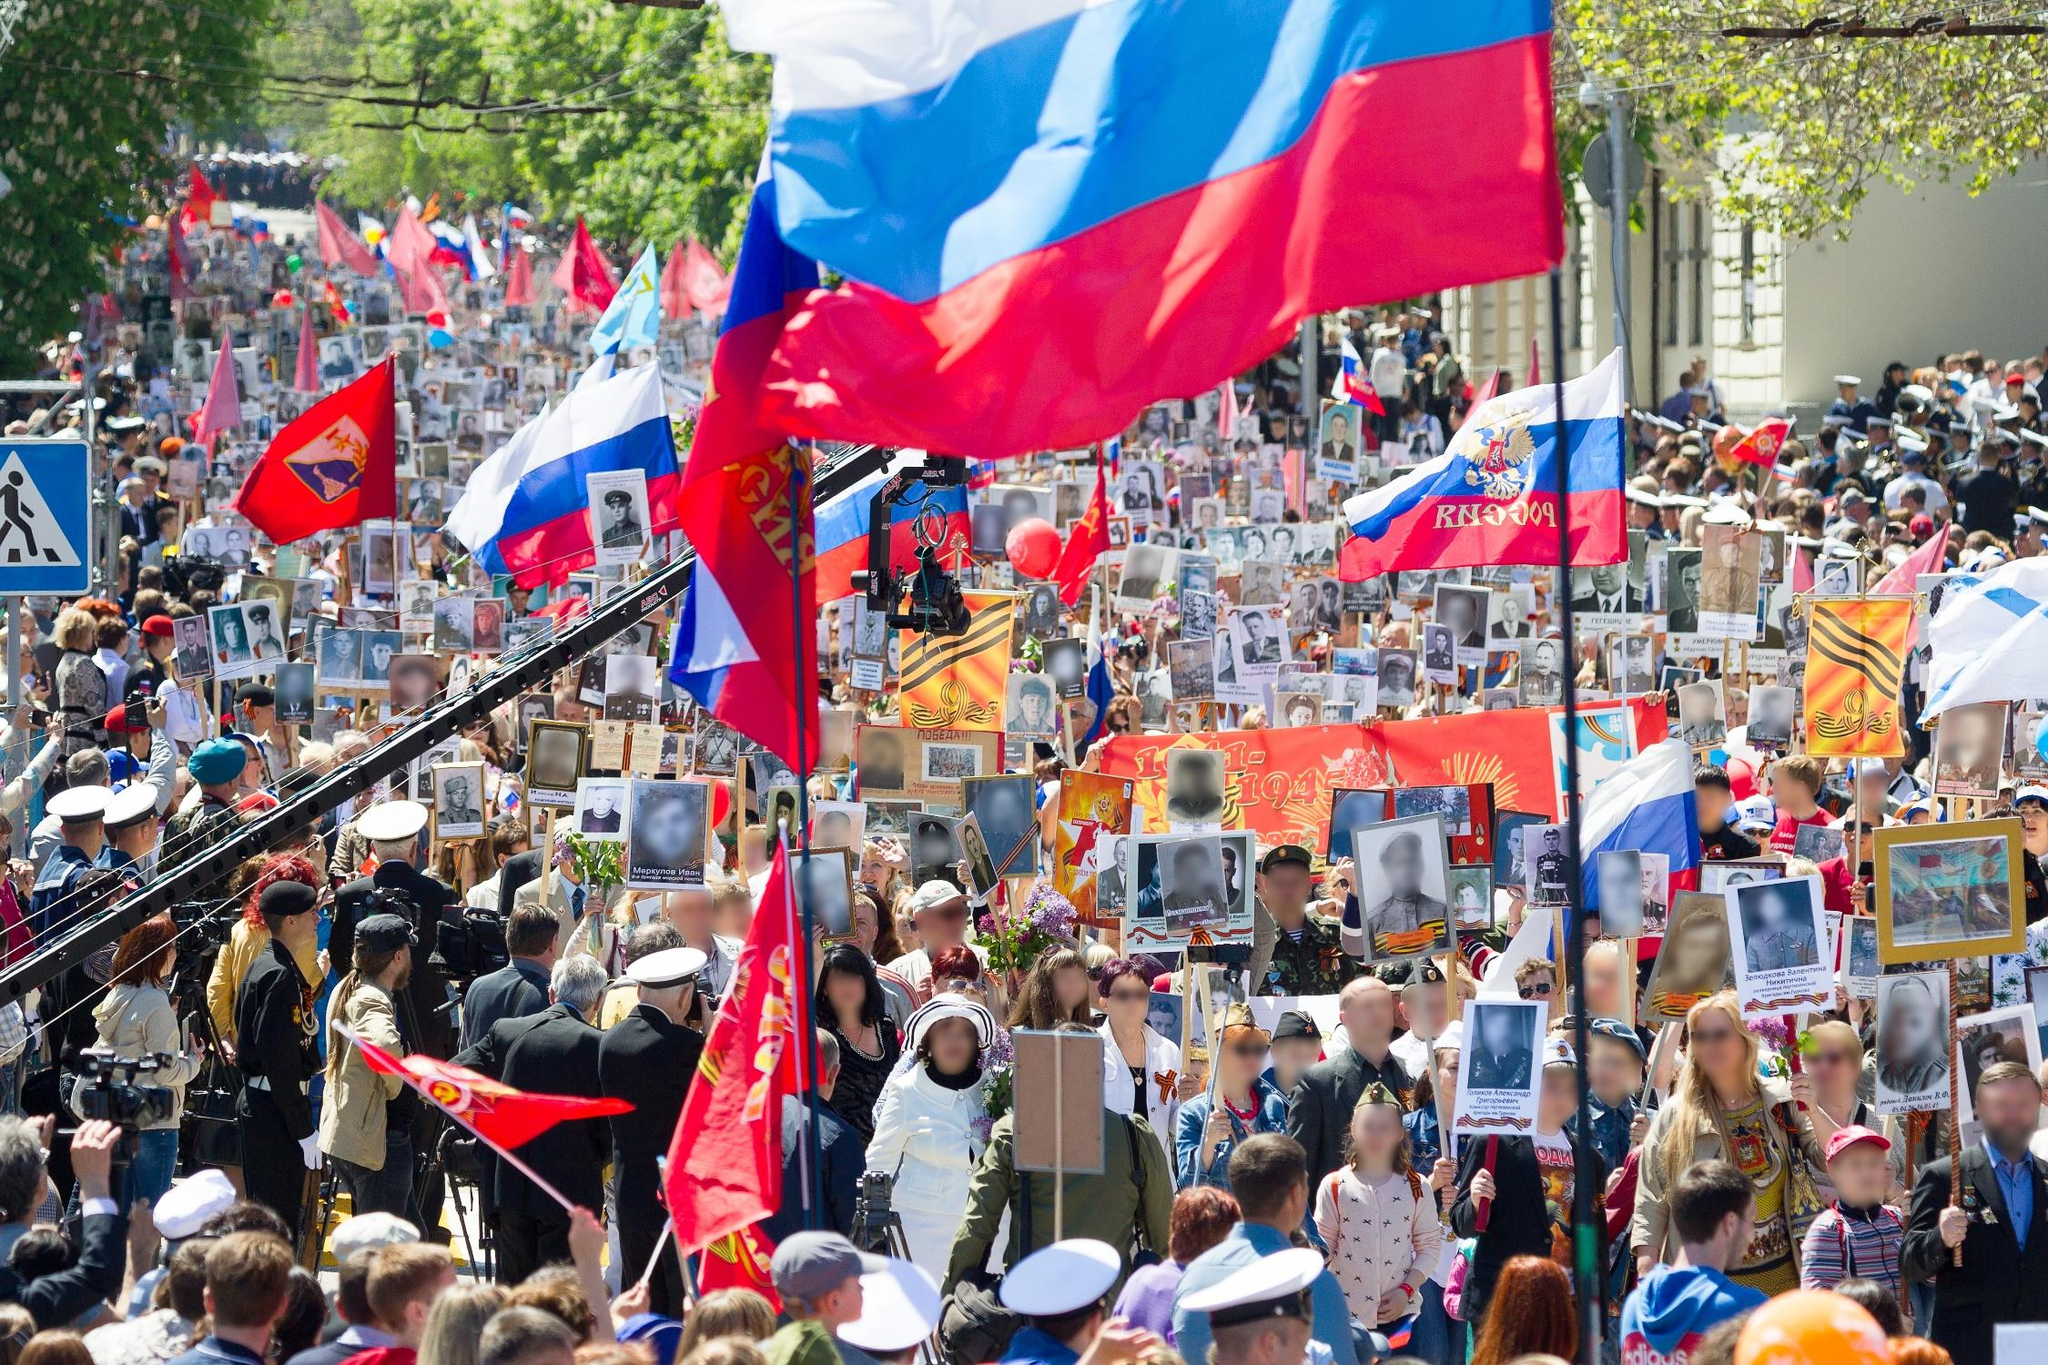Analyze the image in a comprehensive and detailed manner. The image captures a vibrant scene of a large parade, teeming with people. The crowd, a sea of individuals, is marching with a sense of unity and purpose. They are holding up various flags and banners, with the Russian flag and the flag of the Soviet Union being particularly prominent, adding vivid splashes of color to the scene. Participants are also holding up photographs of soldiers and historical figures, likely in remembrance or celebration of past events, possibly related to war veterans or a significant historical date. The high-angle perspective of the photo gives a bird’s-eye view of the crowd, emphasizing the scale of the event and the number of participants involved. Surrounding the crowd, the background features a mix of trees and buildings, which enhance the urban setting of the parade and contrast with the dense assembly of people. Despite the dense crowd, the image conveys a powerful sense of collective memory and commemoration. 